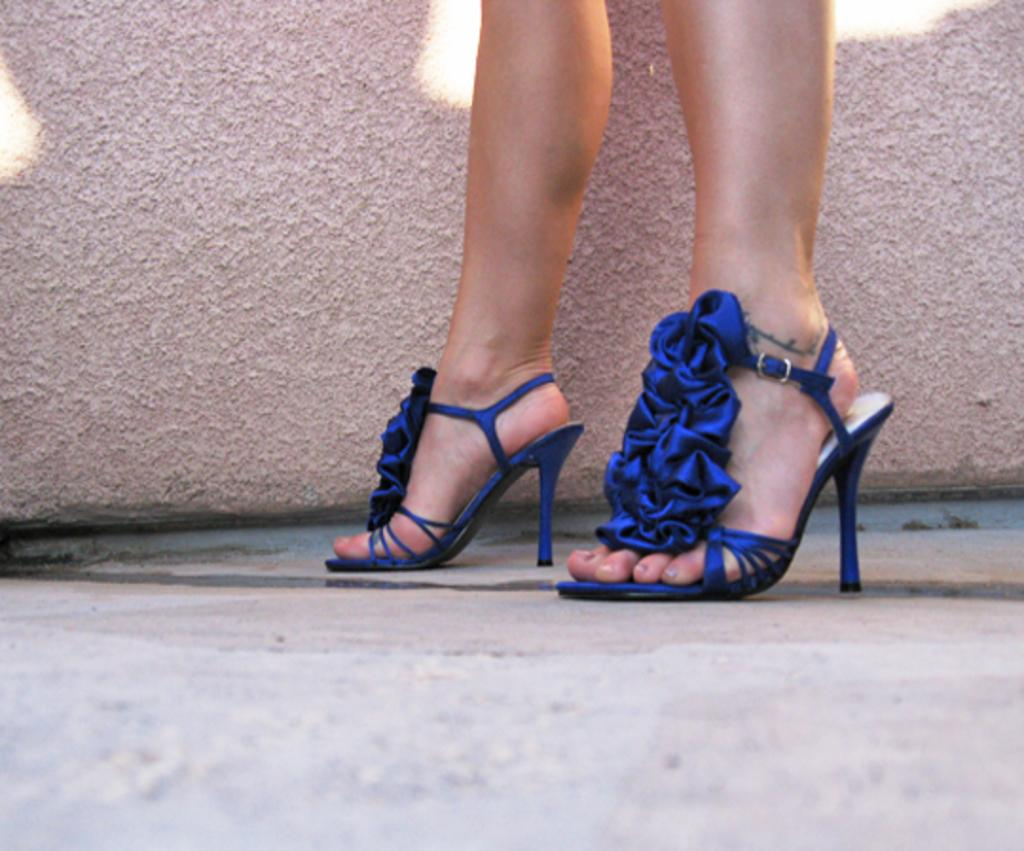Who or what is the main subject in the image? There is a person in the image. What part of the person's body can be seen in the image? The person's legs are visible in the image. What type of footwear is the person wearing? The person is wearing heels. What can be seen behind the person in the image? There is a wall in the background of the image. What is visible at the bottom of the image? The floor is visible at the bottom of the image. What type of destruction can be seen on the coast in the image? There is no coast or destruction present in the image; it features a person with visible legs wearing heels, a wall in the background, and a visible floor. 